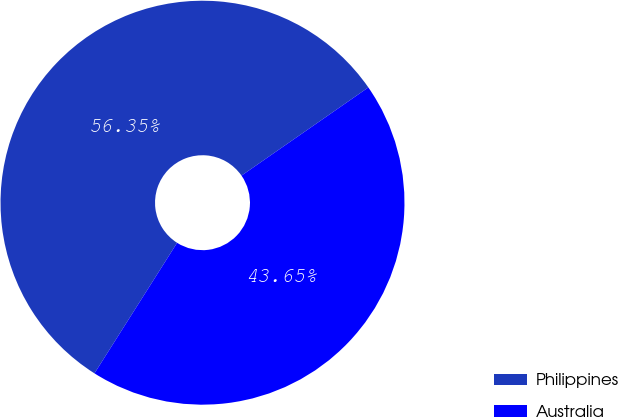Convert chart to OTSL. <chart><loc_0><loc_0><loc_500><loc_500><pie_chart><fcel>Philippines<fcel>Australia<nl><fcel>56.35%<fcel>43.65%<nl></chart> 